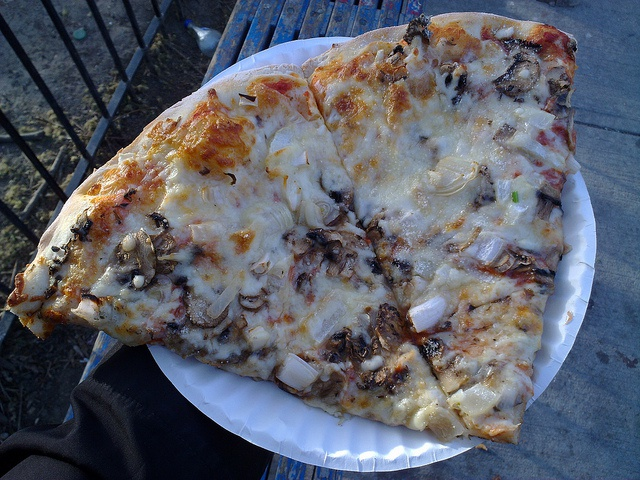Describe the objects in this image and their specific colors. I can see pizza in black, darkgray, and gray tones and people in black and darkblue tones in this image. 